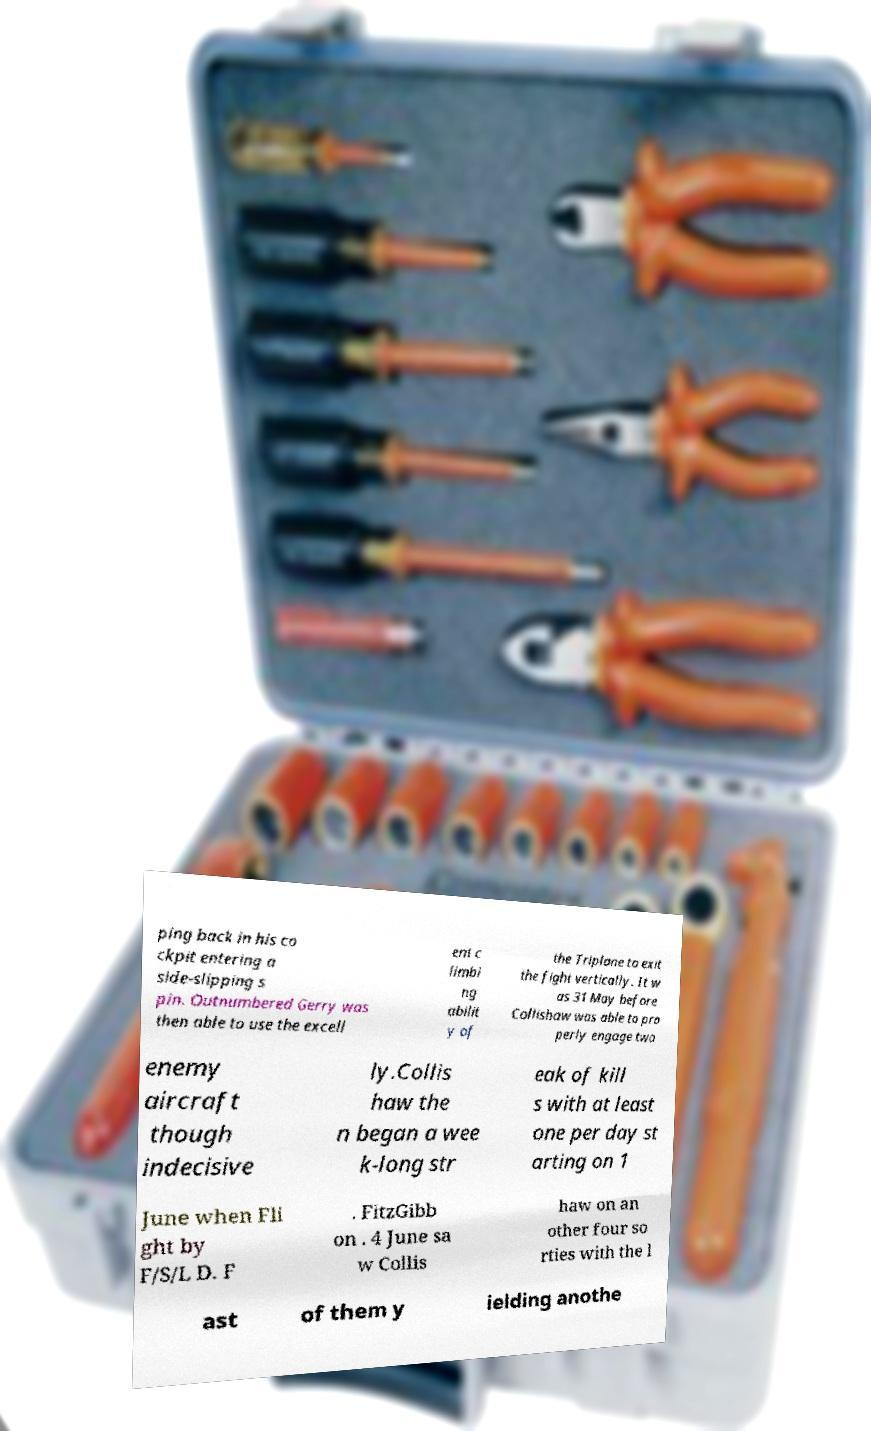Please identify and transcribe the text found in this image. ping back in his co ckpit entering a side-slipping s pin. Outnumbered Gerry was then able to use the excell ent c limbi ng abilit y of the Triplane to exit the fight vertically. It w as 31 May before Collishaw was able to pro perly engage two enemy aircraft though indecisive ly.Collis haw the n began a wee k-long str eak of kill s with at least one per day st arting on 1 June when Fli ght by F/S/L D. F . FitzGibb on . 4 June sa w Collis haw on an other four so rties with the l ast of them y ielding anothe 